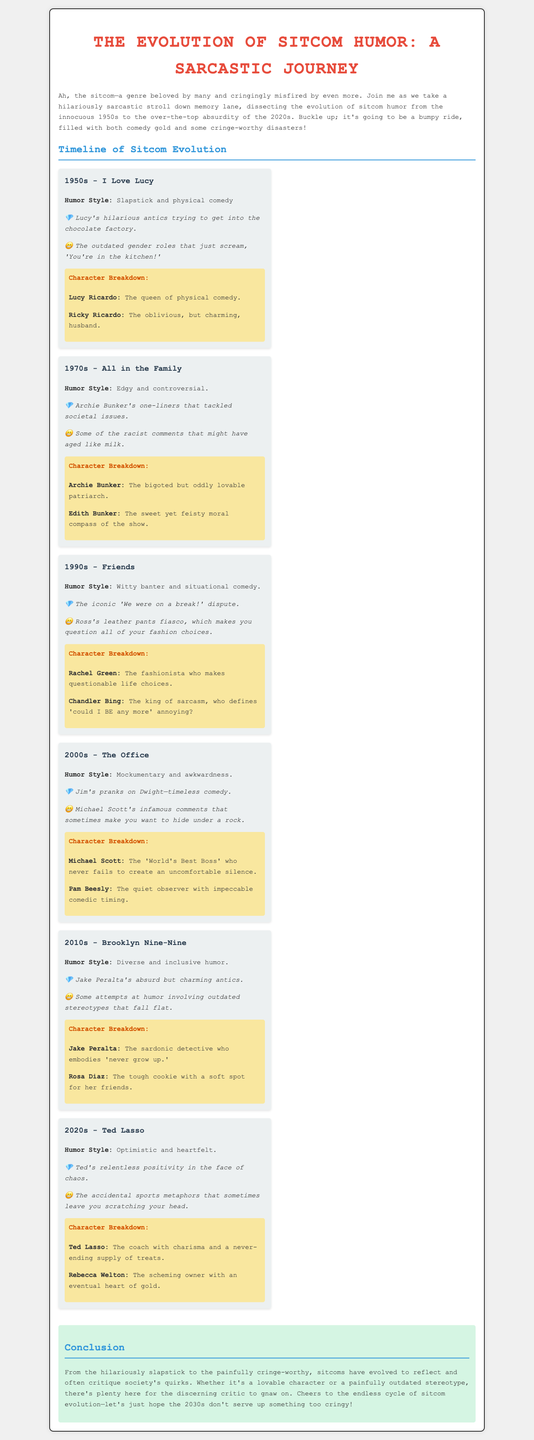what decade is associated with "I Love Lucy"? "I Love Lucy" is primarily from the 1950s, as stated in the document.
Answer: 1950s who is described as the "queen of physical comedy"? The character Lucy Ricardo is referred to as the "queen of physical comedy."
Answer: Lucy Ricardo what humor style is associated with "The Office"? The humor style for "The Office" is described as a mockumentary and awkwardness.
Answer: Mockumentary and awkwardness what iconic moment is mentioned from "Friends"? The document notes the iconic moment of "We were on a break!" as a memorable scene.
Answer: "We were on a break!" which character from Brooklyn Nine-Nine is known for absurd antics? Jake Peralta is noted for his absurd but charming antics in Brooklyn Nine-Nine.
Answer: Jake Peralta what is a cringe-worthy example mentioned from the 1970s? The document mentions some racist comments from the 1970s that might have aged poorly as a cringe-worthy example.
Answer: Racist comments what decade features Ted Lasso? Ted Lasso is from the 2020s, according to the timeline.
Answer: 2020s which character is described with a "never-ending supply of treats"? Ted Lasso is described as the character with a "never-ending supply of treats."
Answer: Ted Lasso what is the humor style of sitcoms in the 2010s? The humor style of sitcoms in the 2010s is described as diverse and inclusive humor.
Answer: Diverse and inclusive humor 